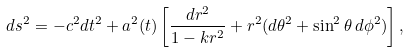<formula> <loc_0><loc_0><loc_500><loc_500>d s ^ { 2 } = - c ^ { 2 } d t ^ { 2 } + a ^ { 2 } ( t ) \left [ \frac { d r ^ { 2 } } { 1 - k r ^ { 2 } } + r ^ { 2 } ( d \theta ^ { 2 } + \sin ^ { 2 } \theta \, d \phi ^ { 2 } ) \right ] ,</formula> 